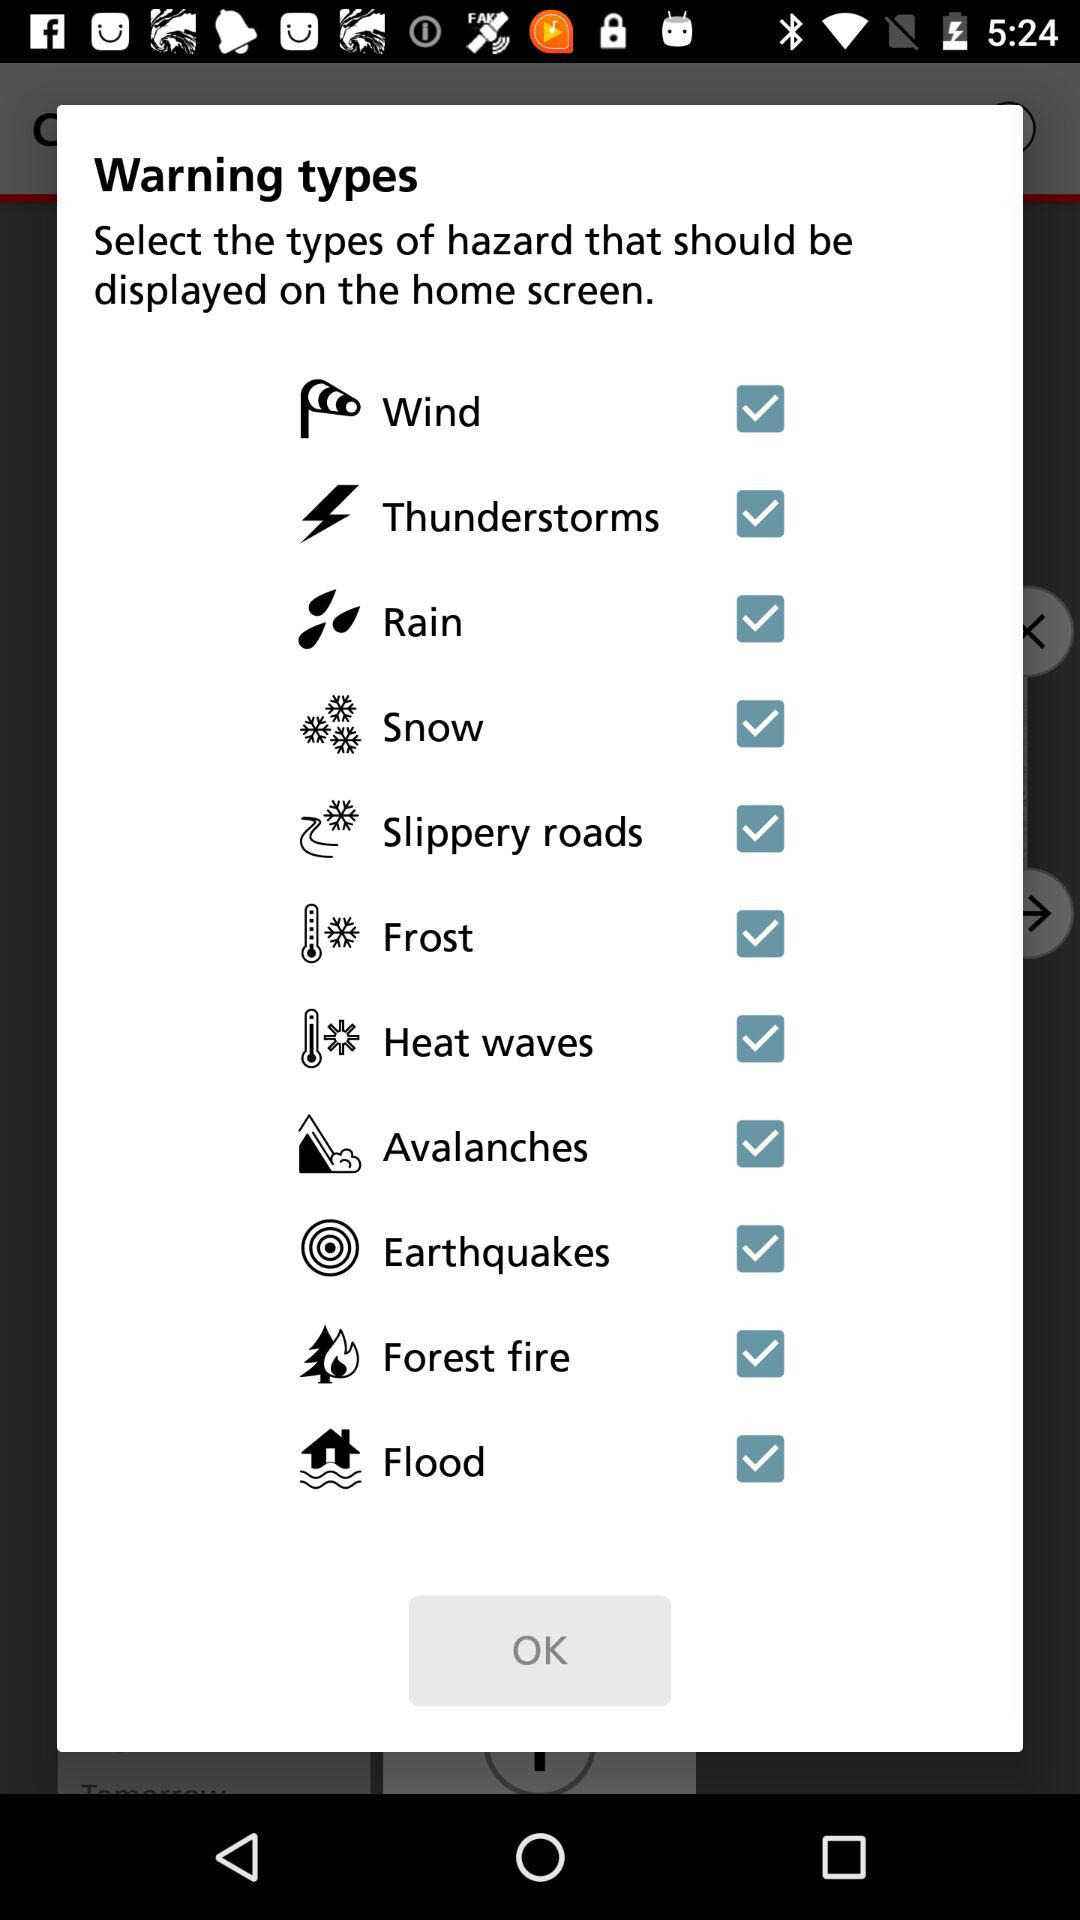What is the status of "Wind"? The status is "on". 